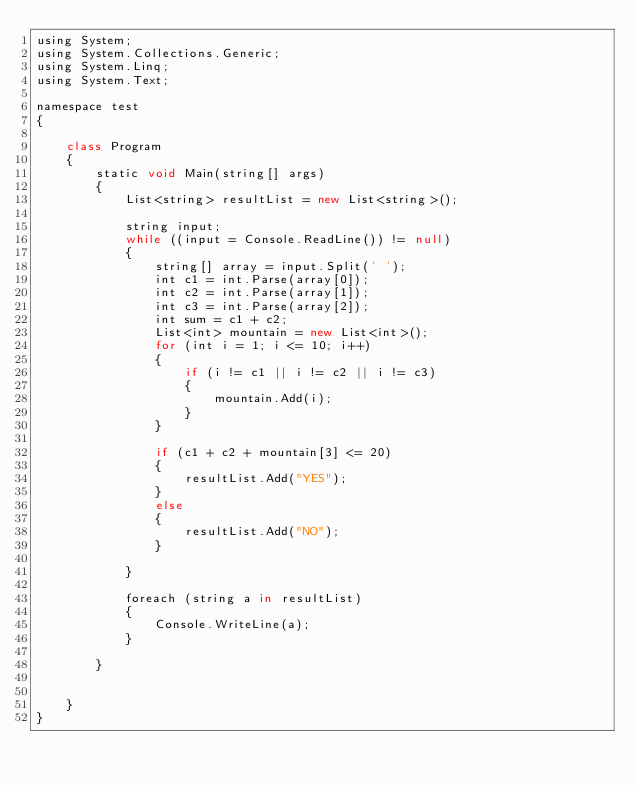Convert code to text. <code><loc_0><loc_0><loc_500><loc_500><_JavaScript_>using System;
using System.Collections.Generic;
using System.Linq;
using System.Text;

namespace test
{

    class Program
    {
        static void Main(string[] args)
        {
            List<string> resultList = new List<string>();

            string input;
            while ((input = Console.ReadLine()) != null)
            {
                string[] array = input.Split(' ');
                int c1 = int.Parse(array[0]);
                int c2 = int.Parse(array[1]);
                int c3 = int.Parse(array[2]);
                int sum = c1 + c2;
                List<int> mountain = new List<int>();
                for (int i = 1; i <= 10; i++)
                {
                    if (i != c1 || i != c2 || i != c3)
                    {
                        mountain.Add(i);
                    }
                }

                if (c1 + c2 + mountain[3] <= 20)
                {
                    resultList.Add("YES");
                }
                else
                {
                    resultList.Add("NO");
                }

            }

            foreach (string a in resultList)
            {
                Console.WriteLine(a);
            }

        }

        
    }
}</code> 